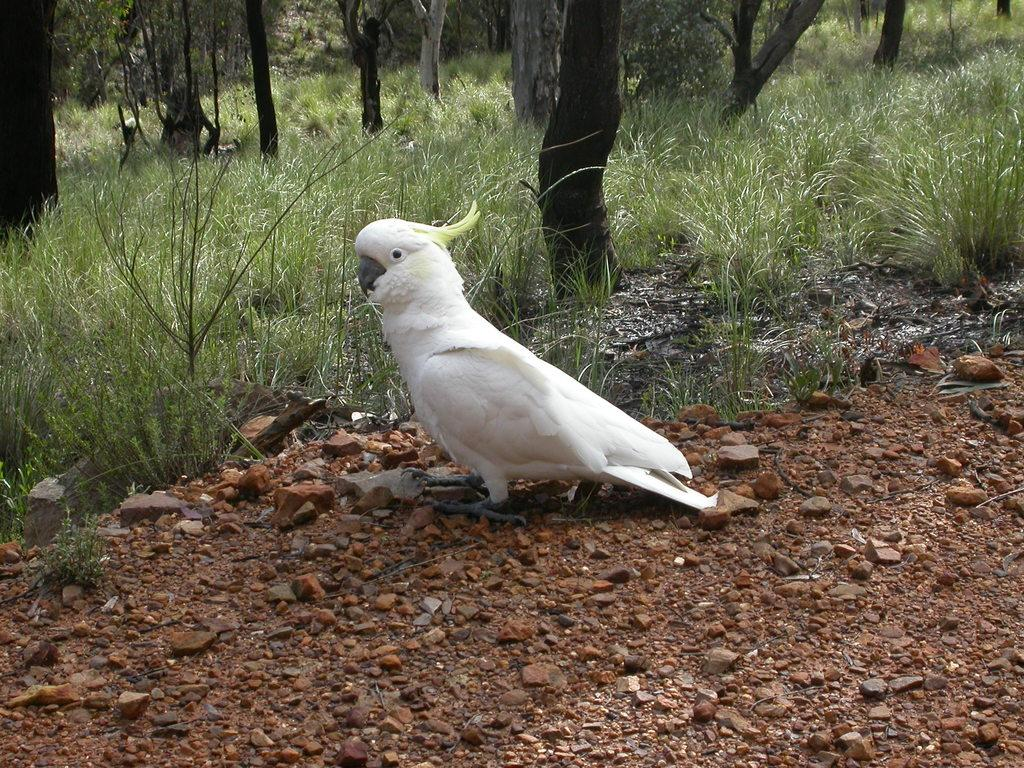What type of animal can be seen in the image? There is a bird in the image. What color is the bird? The bird is white in color. What can be seen in the background of the image? There are trees and grass in the background of the image. What color are the trees and grass? The trees are green in color, and so is the grass. What type of engine can be seen in the image? There is no engine present in the image; it features a white bird and green trees and grass in the background. What is the acoustic quality of the bird's song in the image? The image does not provide any information about the bird's song or its acoustic quality. 